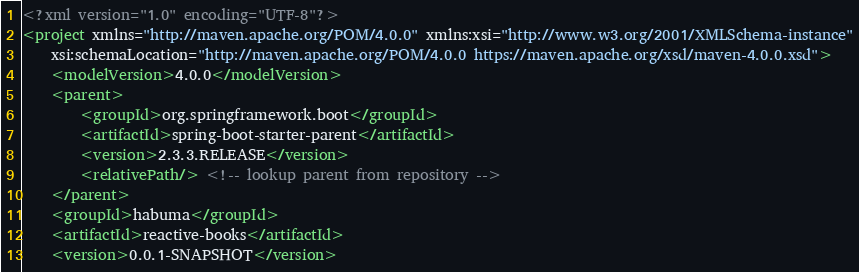<code> <loc_0><loc_0><loc_500><loc_500><_XML_><?xml version="1.0" encoding="UTF-8"?>
<project xmlns="http://maven.apache.org/POM/4.0.0" xmlns:xsi="http://www.w3.org/2001/XMLSchema-instance"
	xsi:schemaLocation="http://maven.apache.org/POM/4.0.0 https://maven.apache.org/xsd/maven-4.0.0.xsd">
	<modelVersion>4.0.0</modelVersion>
	<parent>
		<groupId>org.springframework.boot</groupId>
		<artifactId>spring-boot-starter-parent</artifactId>
		<version>2.3.3.RELEASE</version>
		<relativePath/> <!-- lookup parent from repository -->
	</parent>
	<groupId>habuma</groupId>
	<artifactId>reactive-books</artifactId>
	<version>0.0.1-SNAPSHOT</version></code> 